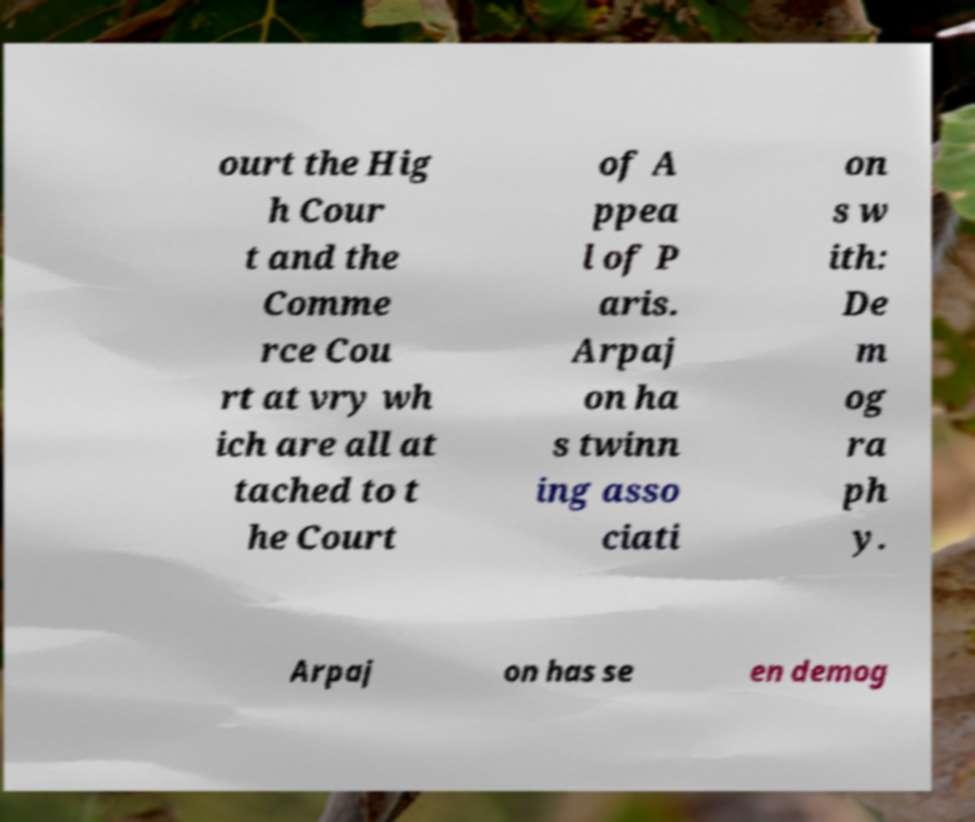Could you assist in decoding the text presented in this image and type it out clearly? ourt the Hig h Cour t and the Comme rce Cou rt at vry wh ich are all at tached to t he Court of A ppea l of P aris. Arpaj on ha s twinn ing asso ciati on s w ith: De m og ra ph y. Arpaj on has se en demog 